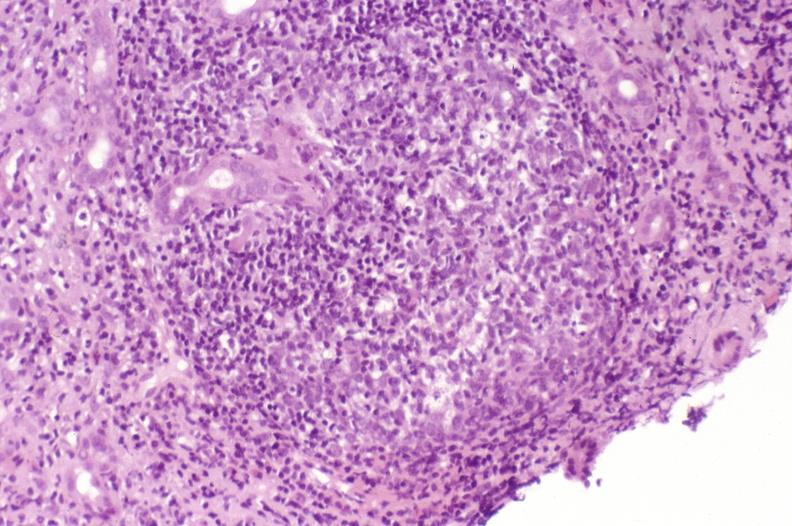s liver present?
Answer the question using a single word or phrase. Yes 